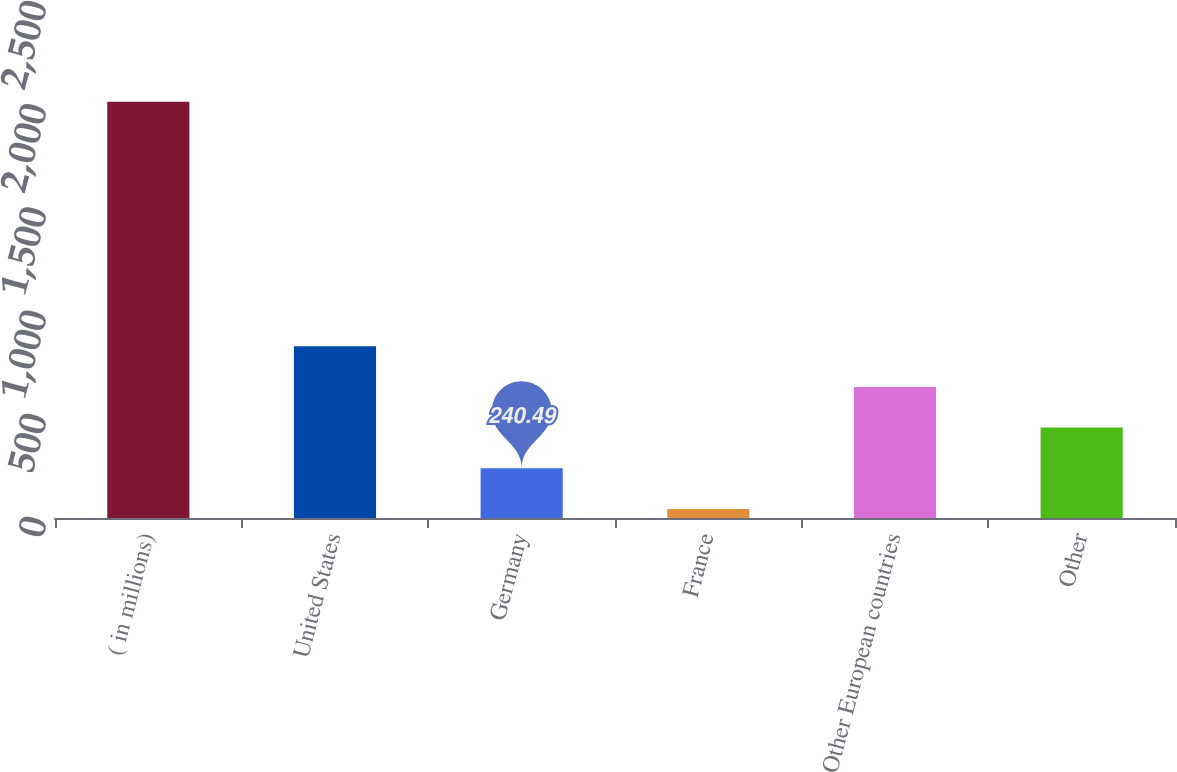Convert chart. <chart><loc_0><loc_0><loc_500><loc_500><bar_chart><fcel>( in millions)<fcel>United States<fcel>Germany<fcel>France<fcel>Other European countries<fcel>Other<nl><fcel>2017<fcel>832.66<fcel>240.49<fcel>43.1<fcel>635.27<fcel>437.88<nl></chart> 